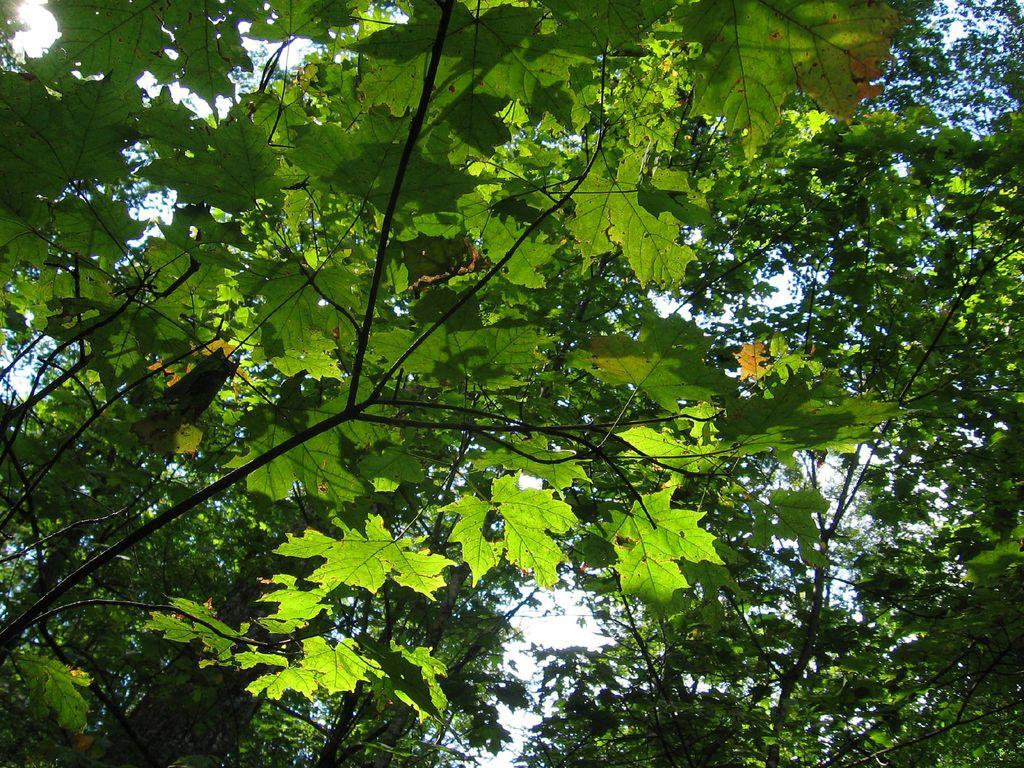What type of vegetation can be seen in the image? There are trees in the image. What features can be observed on the trees? The trees have leaves, stems, and branches. What is visible at the top of the image? The sky is visible at the top of the image. What type of oil can be seen dripping from the trees in the image? There is no oil present in the image; the trees have leaves, stems, and branches. 